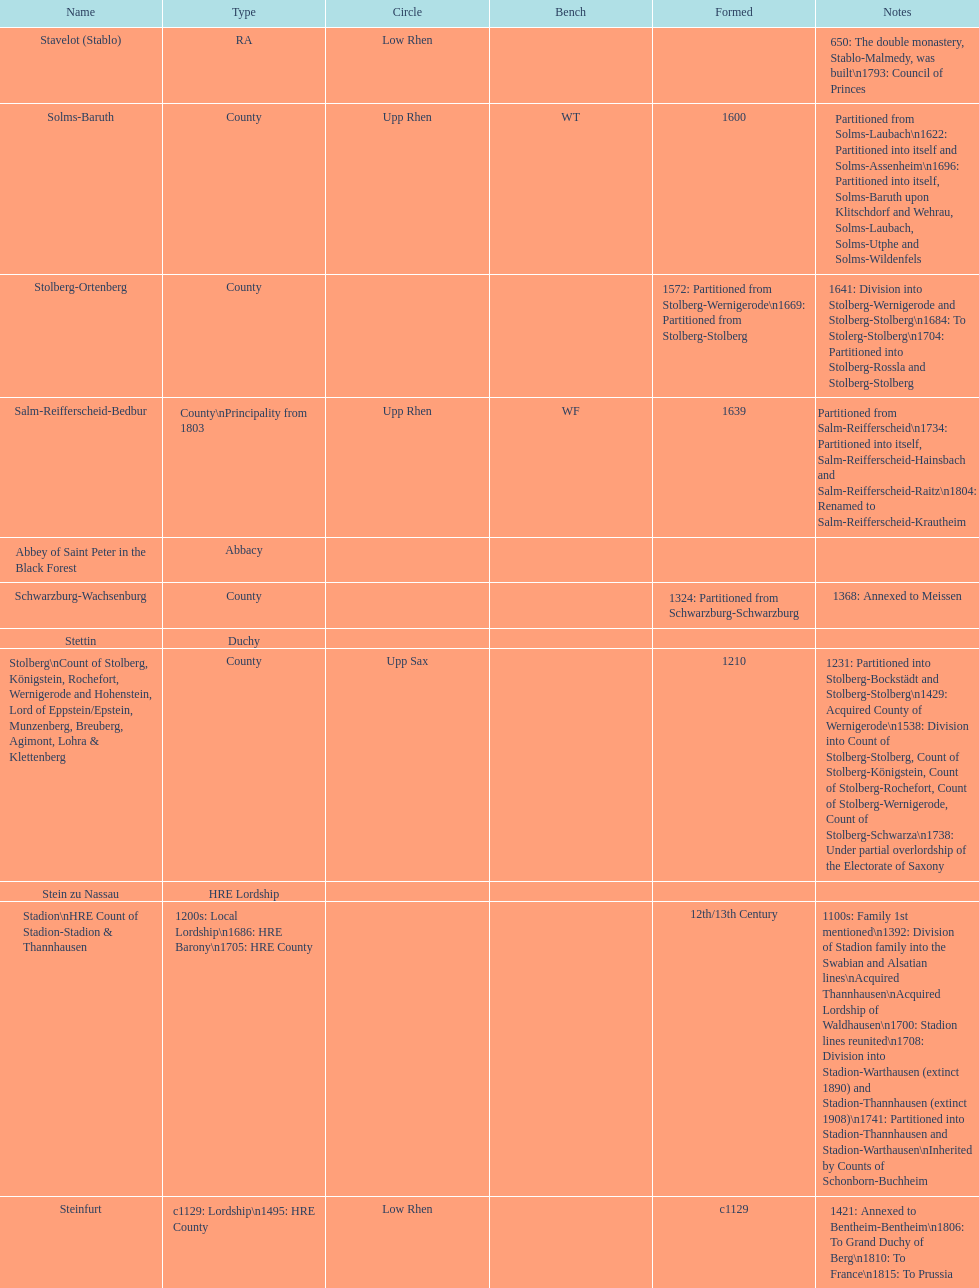What is the state above "sagan"? Saarwerden and Lahr. 